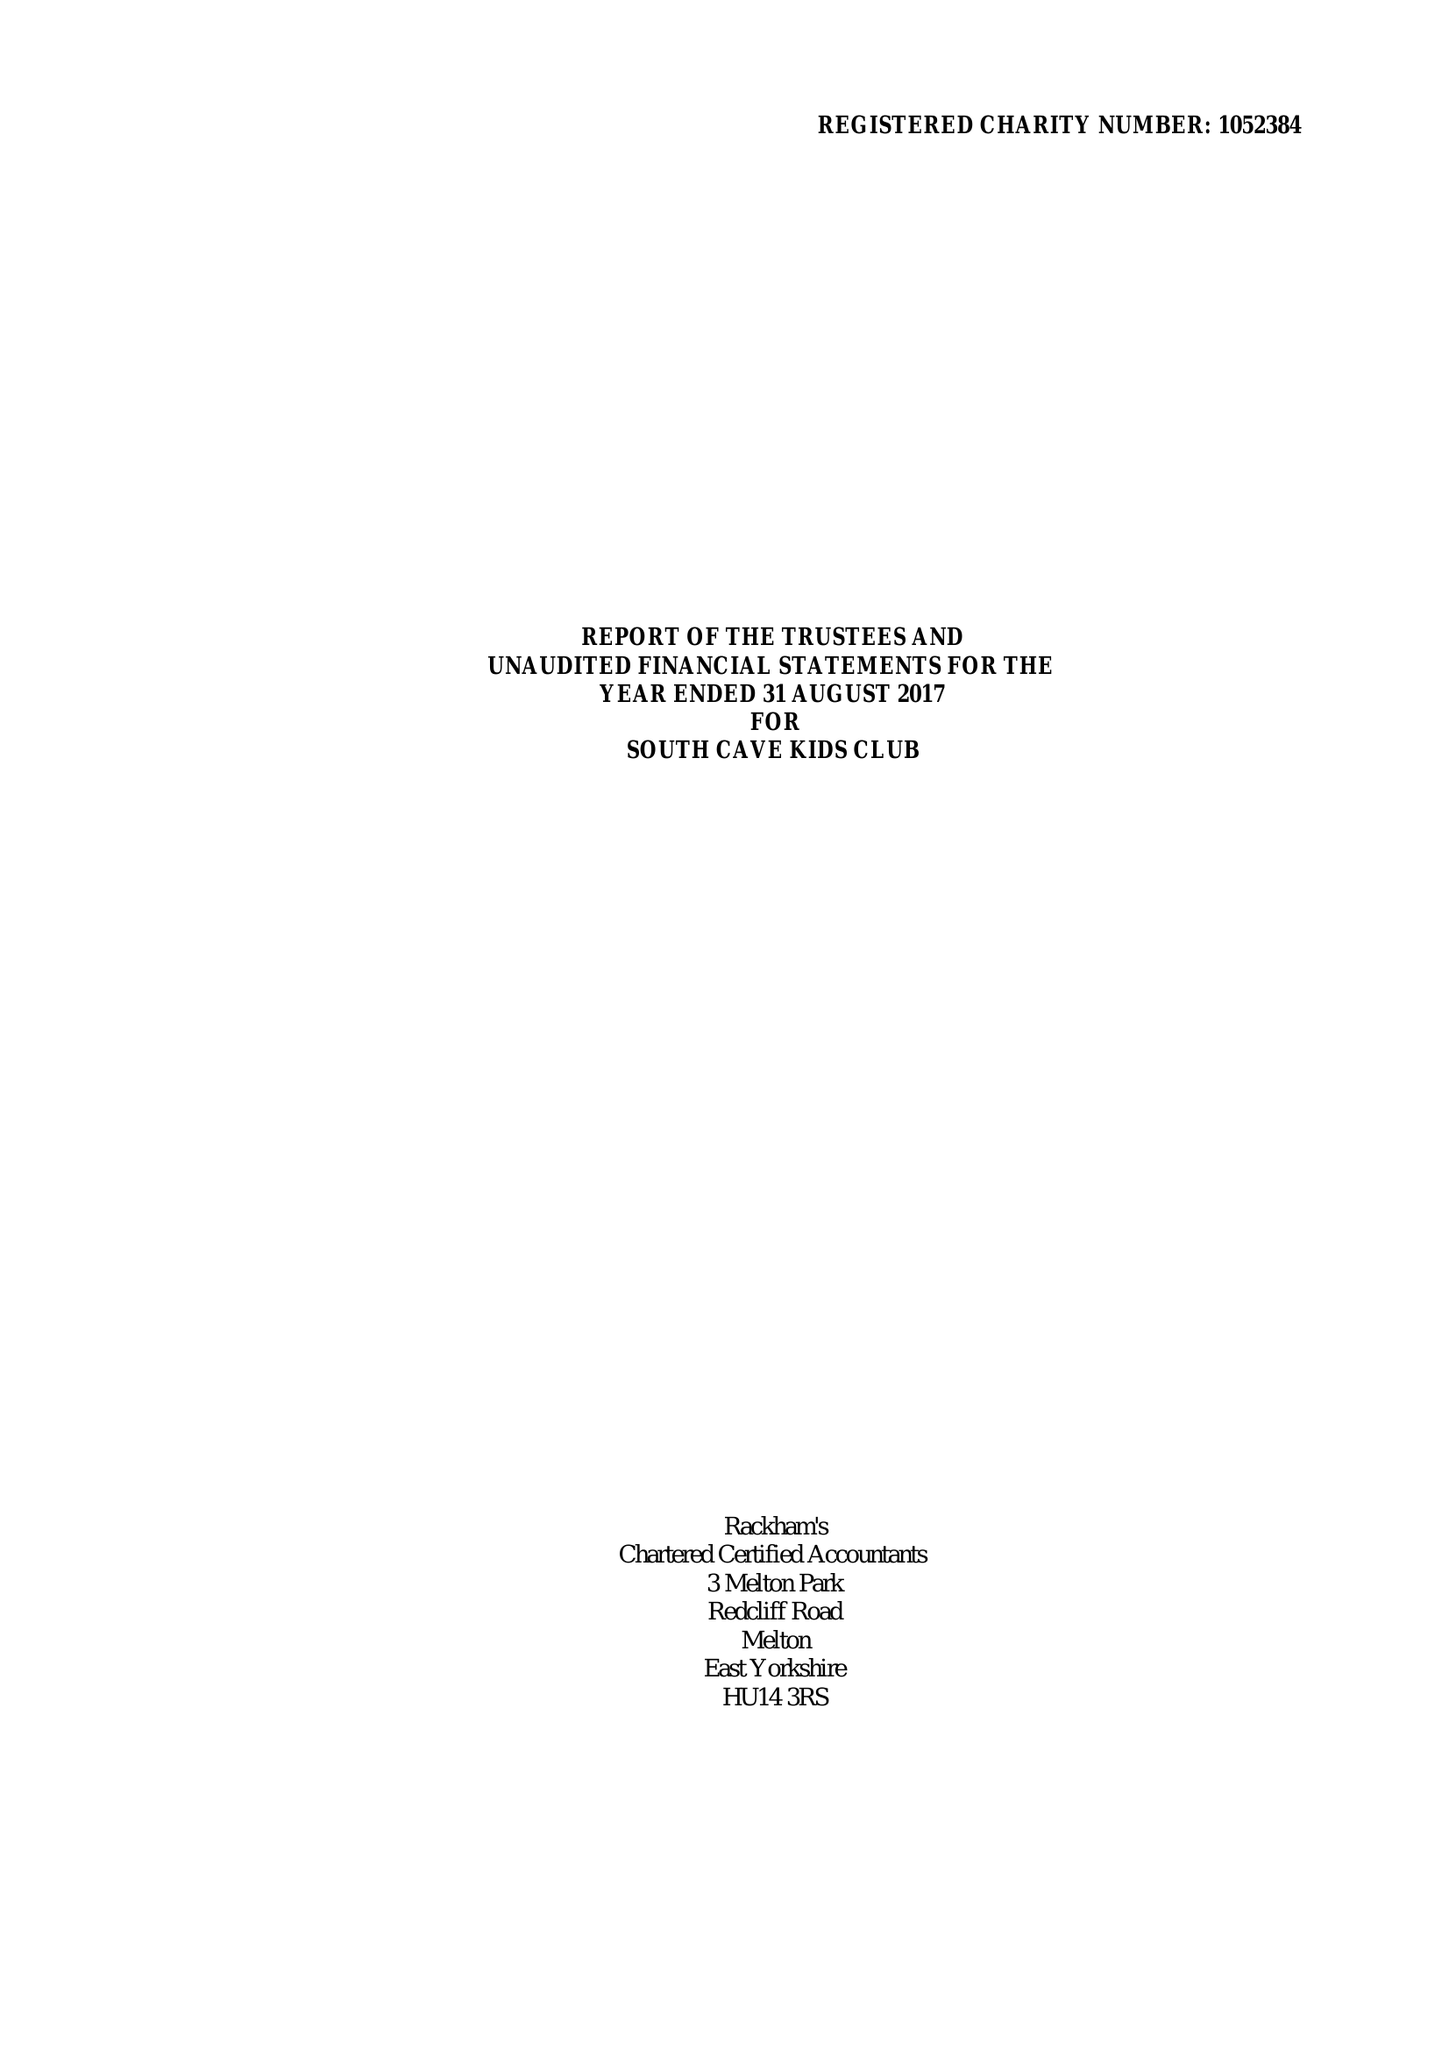What is the value for the report_date?
Answer the question using a single word or phrase. 2017-08-31 